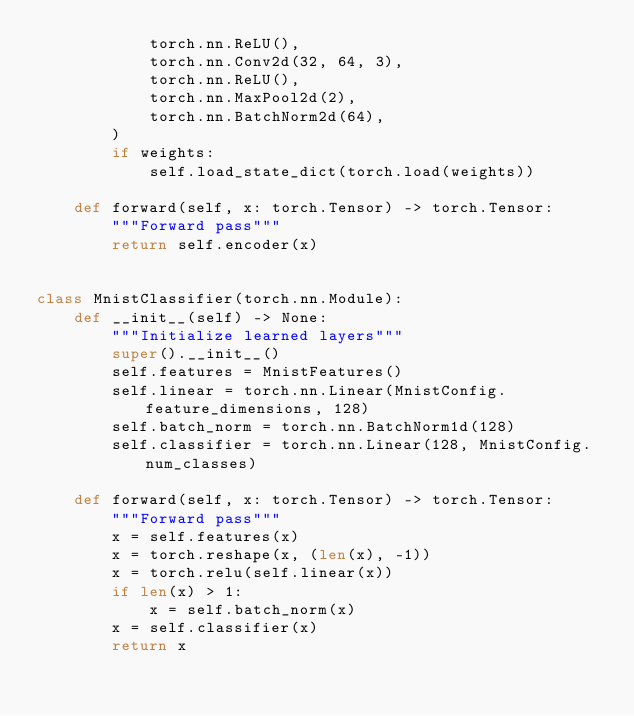Convert code to text. <code><loc_0><loc_0><loc_500><loc_500><_Python_>            torch.nn.ReLU(),
            torch.nn.Conv2d(32, 64, 3),
            torch.nn.ReLU(),
            torch.nn.MaxPool2d(2),
            torch.nn.BatchNorm2d(64),
        )
        if weights:
            self.load_state_dict(torch.load(weights))

    def forward(self, x: torch.Tensor) -> torch.Tensor:
        """Forward pass"""
        return self.encoder(x)


class MnistClassifier(torch.nn.Module):
    def __init__(self) -> None:
        """Initialize learned layers"""
        super().__init__()
        self.features = MnistFeatures()
        self.linear = torch.nn.Linear(MnistConfig.feature_dimensions, 128)
        self.batch_norm = torch.nn.BatchNorm1d(128)
        self.classifier = torch.nn.Linear(128, MnistConfig.num_classes)

    def forward(self, x: torch.Tensor) -> torch.Tensor:
        """Forward pass"""
        x = self.features(x)
        x = torch.reshape(x, (len(x), -1))
        x = torch.relu(self.linear(x))
        if len(x) > 1:
            x = self.batch_norm(x)
        x = self.classifier(x)
        return x
</code> 